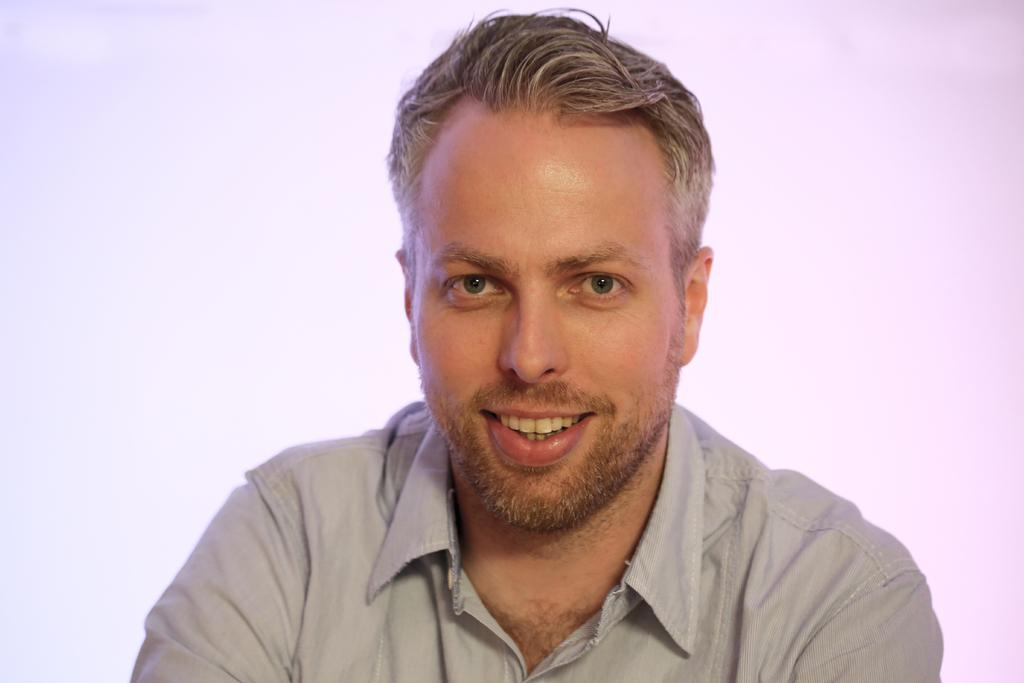Who is present in the image? There is a man in the image. What is the man wearing in the image? The man is wearing a gray shirt in the image. What is the color of the background in the image? The background of the image is white. How many pizzas can be seen in the image? There are no pizzas present in the image. Is the man playing basketball in the image? There is no indication of basketball or any sports activity in the image. 